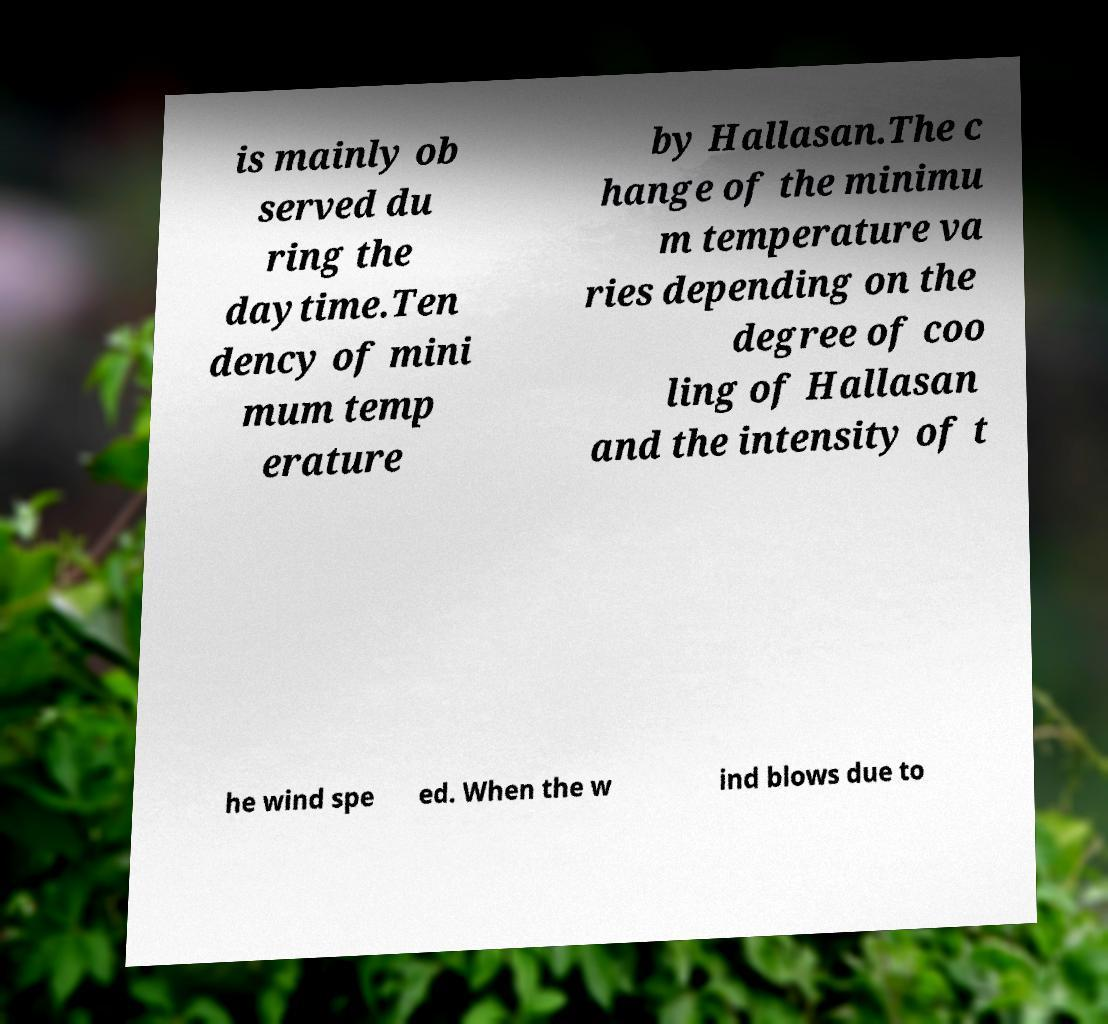There's text embedded in this image that I need extracted. Can you transcribe it verbatim? is mainly ob served du ring the daytime.Ten dency of mini mum temp erature by Hallasan.The c hange of the minimu m temperature va ries depending on the degree of coo ling of Hallasan and the intensity of t he wind spe ed. When the w ind blows due to 